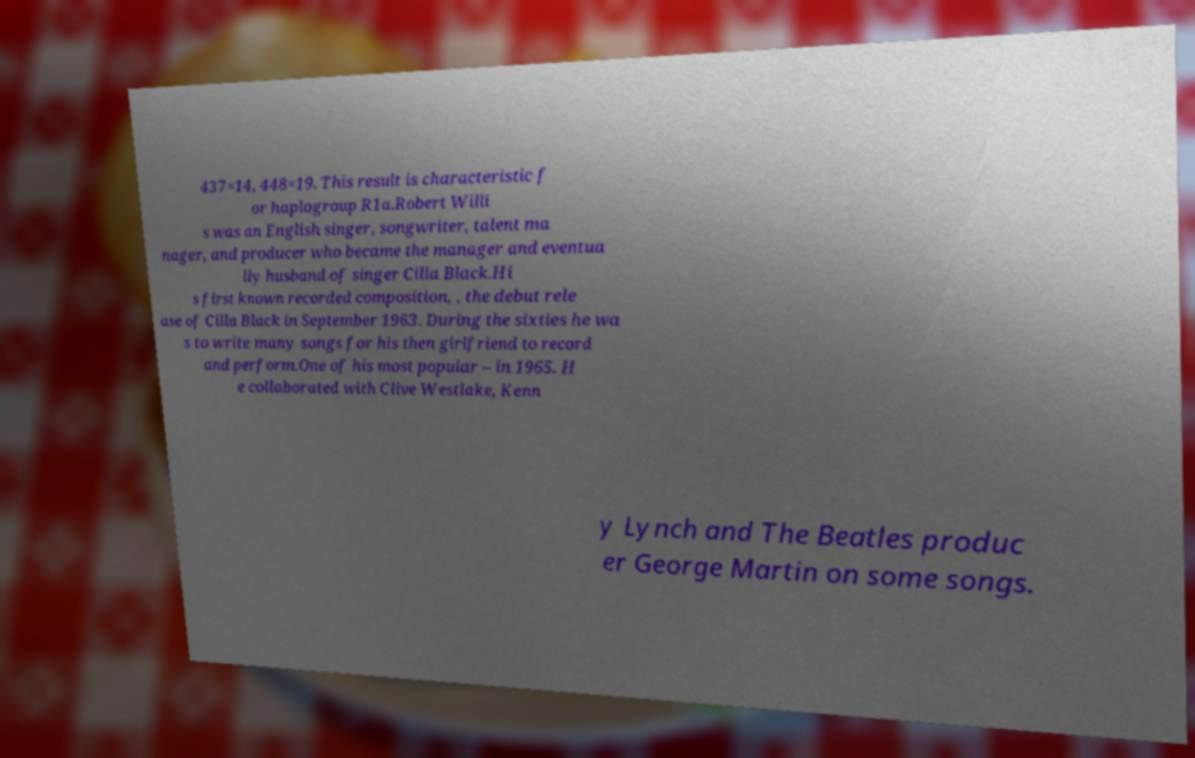There's text embedded in this image that I need extracted. Can you transcribe it verbatim? 437=14, 448=19. This result is characteristic f or haplogroup R1a.Robert Willi s was an English singer, songwriter, talent ma nager, and producer who became the manager and eventua lly husband of singer Cilla Black.Hi s first known recorded composition, , the debut rele ase of Cilla Black in September 1963. During the sixties he wa s to write many songs for his then girlfriend to record and perform.One of his most popular – in 1965. H e collaborated with Clive Westlake, Kenn y Lynch and The Beatles produc er George Martin on some songs. 